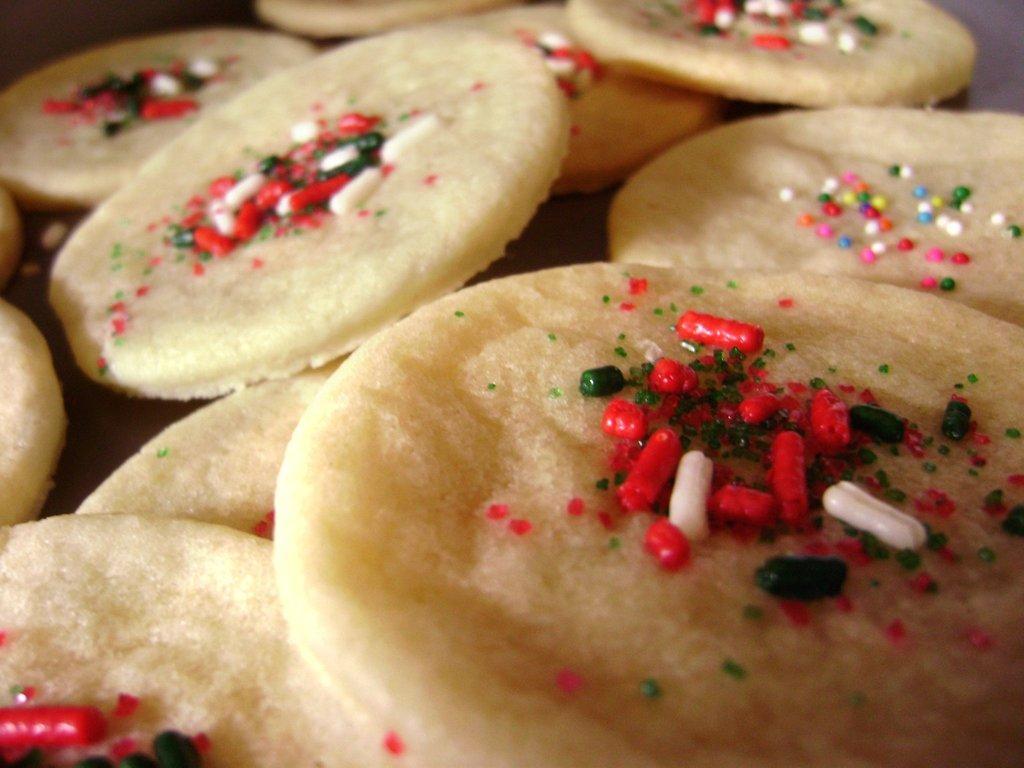In one or two sentences, can you explain what this image depicts? In the center of the image there are food items. 